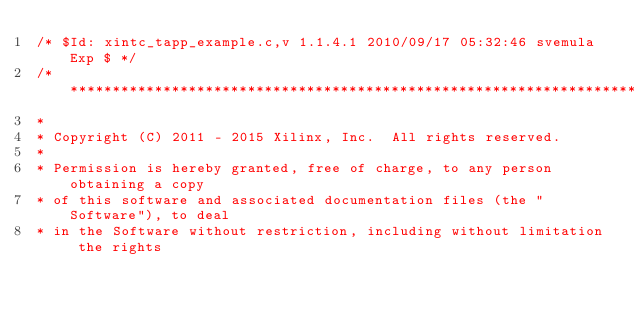Convert code to text. <code><loc_0><loc_0><loc_500><loc_500><_C_>/* $Id: xintc_tapp_example.c,v 1.1.4.1 2010/09/17 05:32:46 svemula Exp $ */
/******************************************************************************
*
* Copyright (C) 2011 - 2015 Xilinx, Inc.  All rights reserved.
*
* Permission is hereby granted, free of charge, to any person obtaining a copy
* of this software and associated documentation files (the "Software"), to deal
* in the Software without restriction, including without limitation the rights</code> 